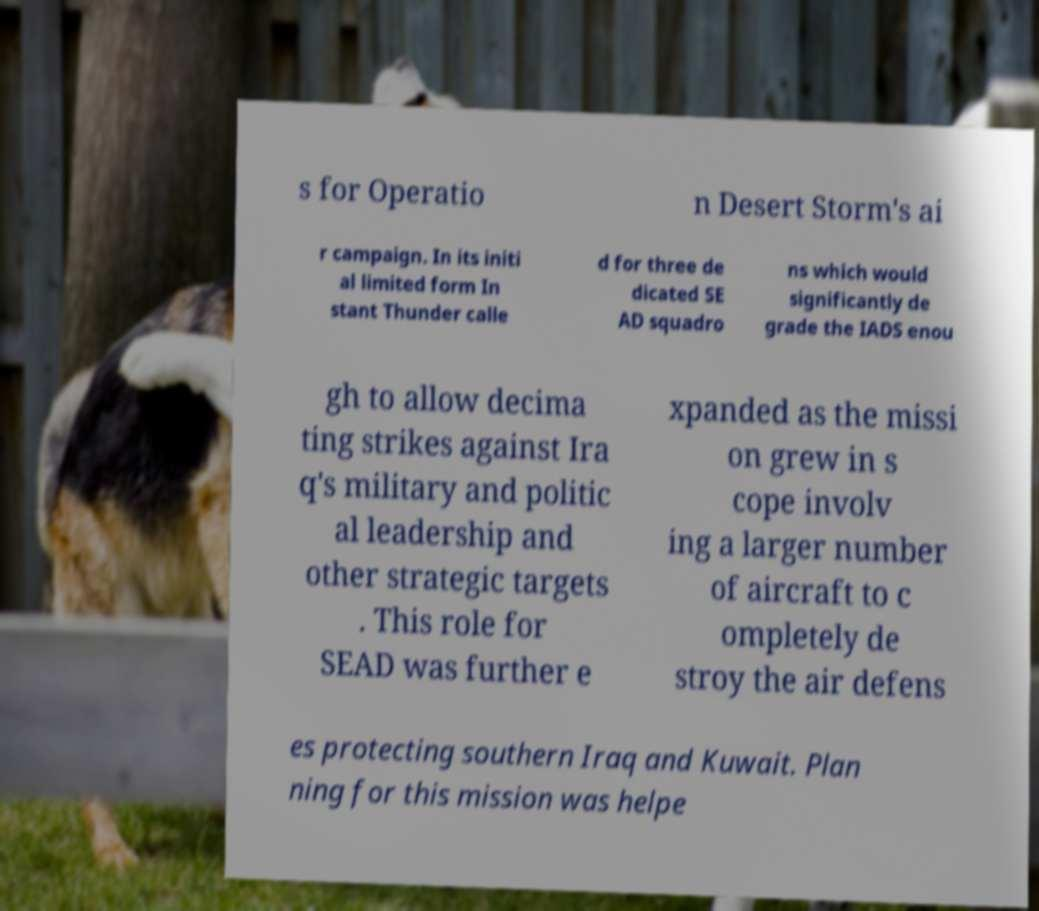For documentation purposes, I need the text within this image transcribed. Could you provide that? s for Operatio n Desert Storm's ai r campaign. In its initi al limited form In stant Thunder calle d for three de dicated SE AD squadro ns which would significantly de grade the IADS enou gh to allow decima ting strikes against Ira q's military and politic al leadership and other strategic targets . This role for SEAD was further e xpanded as the missi on grew in s cope involv ing a larger number of aircraft to c ompletely de stroy the air defens es protecting southern Iraq and Kuwait. Plan ning for this mission was helpe 